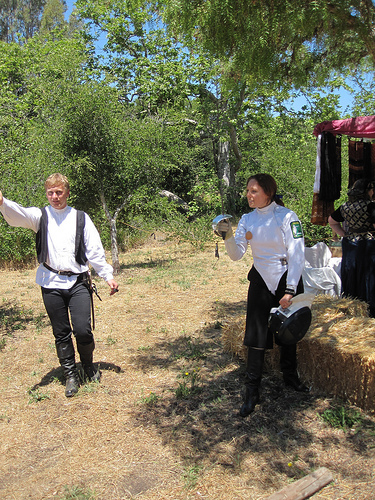<image>
Can you confirm if the boy is in front of the girl? No. The boy is not in front of the girl. The spatial positioning shows a different relationship between these objects. 